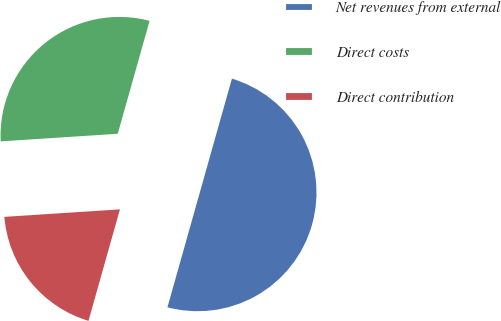Convert chart to OTSL. <chart><loc_0><loc_0><loc_500><loc_500><pie_chart><fcel>Net revenues from external<fcel>Direct costs<fcel>Direct contribution<nl><fcel>50.0%<fcel>30.41%<fcel>19.59%<nl></chart> 